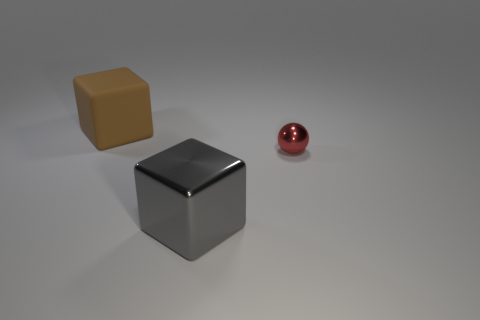Can you infer anything about the lighting in the scene based on the shadows? Based on the shadows, there appears to be a single light source originating from the upper left, casting diagonal shadows to the lower right. This suggests a somewhat directional light, although the softness of the shadows indicates that the light source is not very close to the objects. 